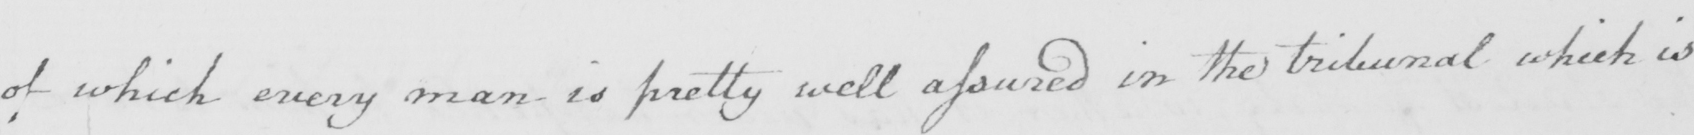Can you tell me what this handwritten text says? of which every man is pretty well assured in the tribunal which is 